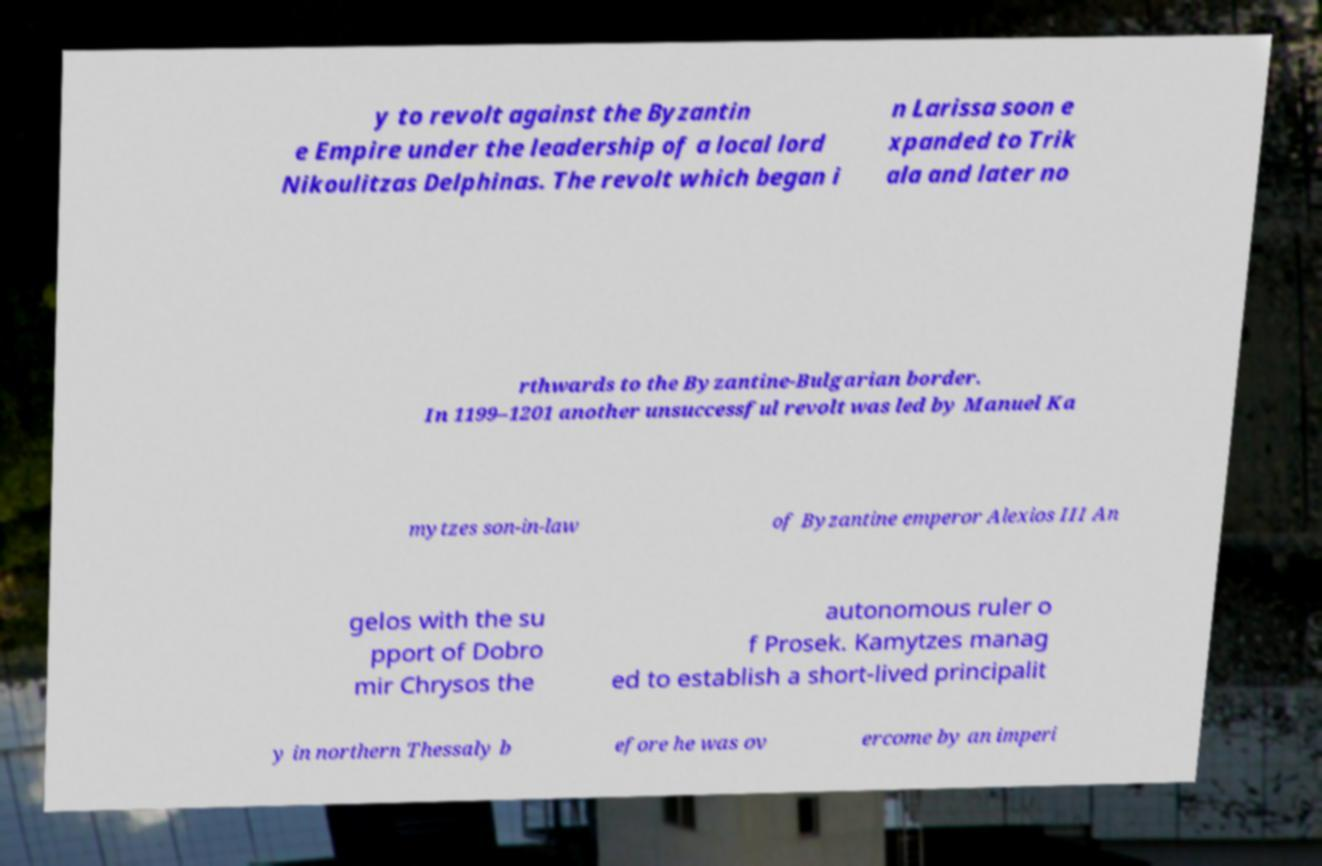Please read and relay the text visible in this image. What does it say? y to revolt against the Byzantin e Empire under the leadership of a local lord Nikoulitzas Delphinas. The revolt which began i n Larissa soon e xpanded to Trik ala and later no rthwards to the Byzantine-Bulgarian border. In 1199–1201 another unsuccessful revolt was led by Manuel Ka mytzes son-in-law of Byzantine emperor Alexios III An gelos with the su pport of Dobro mir Chrysos the autonomous ruler o f Prosek. Kamytzes manag ed to establish a short-lived principalit y in northern Thessaly b efore he was ov ercome by an imperi 